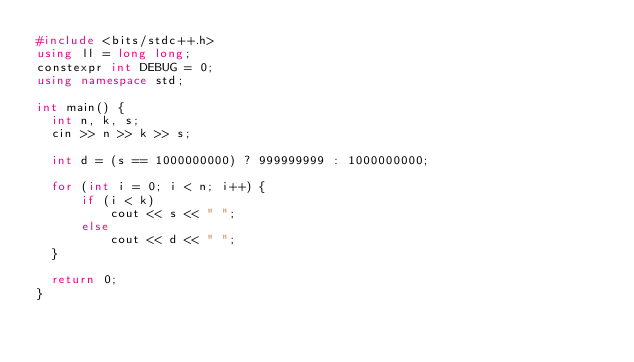<code> <loc_0><loc_0><loc_500><loc_500><_C++_>#include <bits/stdc++.h>
using ll = long long;
constexpr int DEBUG = 0;
using namespace std;

int main() {
  int n, k, s;
  cin >> n >> k >> s;
  
  int d = (s == 1000000000) ? 999999999 : 1000000000;
  
  for (int i = 0; i < n; i++) {
      if (i < k)
          cout << s << " ";
      else
          cout << d << " ";
  }
  
  return 0;
}</code> 